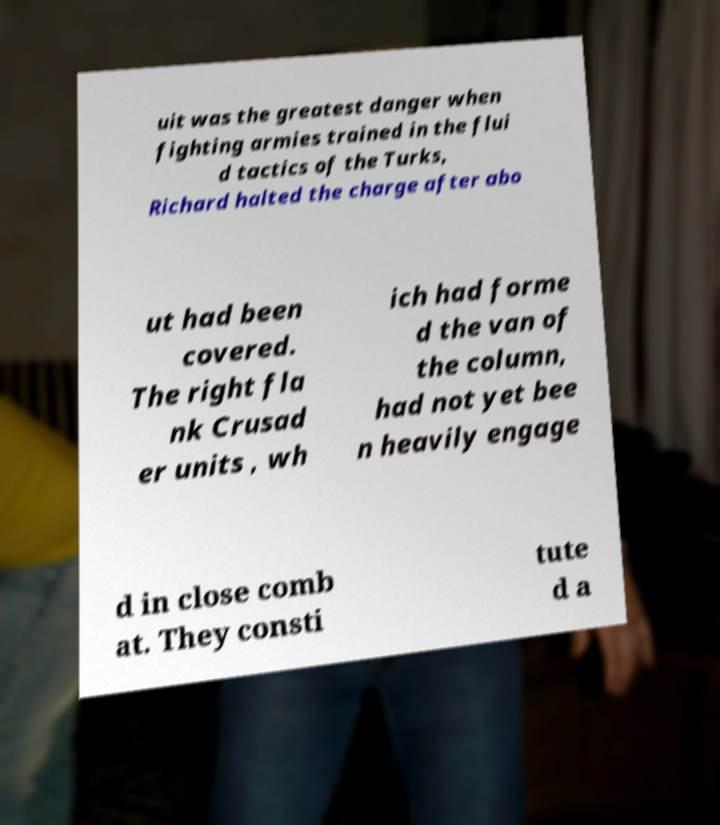Could you extract and type out the text from this image? uit was the greatest danger when fighting armies trained in the flui d tactics of the Turks, Richard halted the charge after abo ut had been covered. The right fla nk Crusad er units , wh ich had forme d the van of the column, had not yet bee n heavily engage d in close comb at. They consti tute d a 